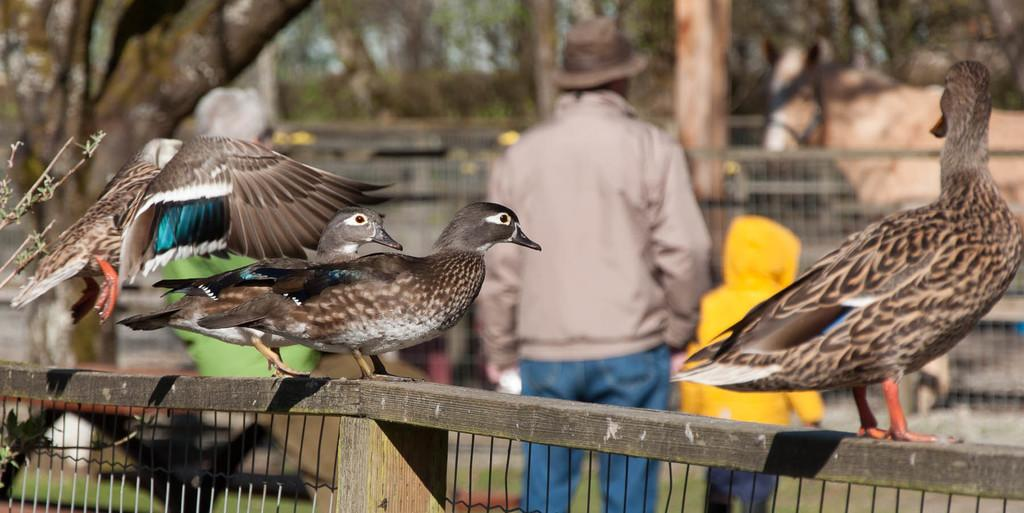How many birds can be seen in the image? There are three birds in the image. Where are the birds located? The birds are on fencing in the image. What can be seen in the background of the image? There are persons standing and trees in the background of the image. What is present in the image besides the birds? There is fencing in the image. What type of destruction is being caused by the giants in the image? There are no giants present in the image, so no destruction can be observed. How many deaths have occurred due to the actions of the birds in the image? There is no indication of any deaths or actions by the birds in the image. 